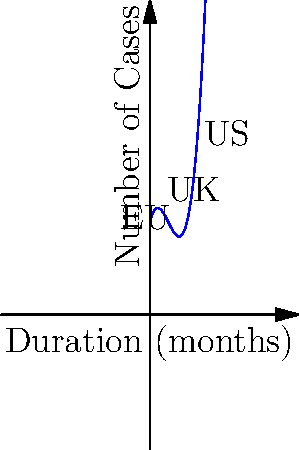The graph represents the polynomial curve of court case durations in different jurisdictions. If $f(x) = 0.5x^3 - 3x^2 + 4x + 10$ represents this curve, where $x$ is the duration in months and $f(x)$ is the number of cases, at what duration does the number of cases in the EU jurisdiction reach its minimum? To find the minimum point of the function for the EU jurisdiction, we need to follow these steps:

1) The minimum point occurs where the derivative of the function equals zero. Let's find the derivative:

   $f'(x) = 1.5x^2 - 6x + 4$

2) Set the derivative to zero and solve the quadratic equation:

   $1.5x^2 - 6x + 4 = 0$

3) This can be simplified to:

   $3x^2 - 12x + 8 = 0$

4) Using the quadratic formula $x = \frac{-b \pm \sqrt{b^2 - 4ac}}{2a}$, where $a=3$, $b=-12$, and $c=8$:

   $x = \frac{12 \pm \sqrt{144 - 96}}{6} = \frac{12 \pm \sqrt{48}}{6} = \frac{12 \pm 4\sqrt{3}}{6}$

5) This gives us two solutions:

   $x_1 = \frac{12 + 4\sqrt{3}}{6} = 2 + \frac{2\sqrt{3}}{3}$ and $x_2 = \frac{12 - 4\sqrt{3}}{6} = 2 - \frac{2\sqrt{3}}{3}$

6) The smaller value, $x_2$, corresponds to the minimum point.

7) The EU jurisdiction is represented at $x=3$ on the graph, which is closer to $x_2$.

Therefore, the number of cases in the EU jurisdiction reaches its minimum at approximately $2 - \frac{2\sqrt{3}}{3}$ months.
Answer: $2 - \frac{2\sqrt{3}}{3}$ months 